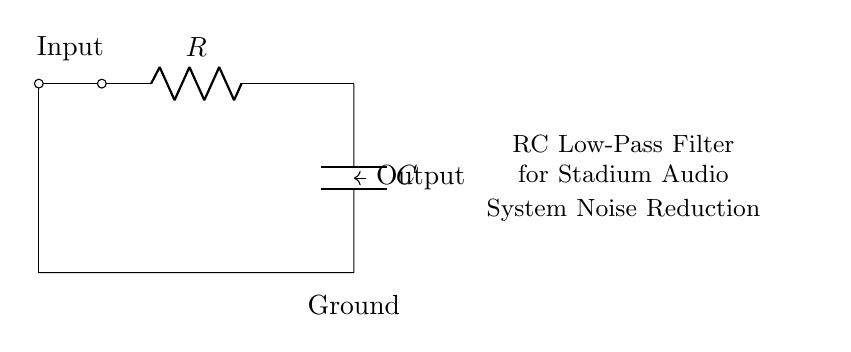What are the components in the circuit? The components visible in the circuit diagram are a resistor and a capacitor. These are essential to the functioning of the RC low-pass filter.
Answer: Resistor and capacitor What is the configuration of the circuit? The circuit is an RC low-pass filter where the resistor is connected in series with the capacitor, which is connected to ground. This arrangement allows low-frequency signals to pass while attenuating high-frequency noise.
Answer: Series configuration What does the input node do? The input node is where the audio signal enters the circuit, which will be filtered to reduce noise before reaching the output.
Answer: Filters audio signal What is the purpose of the capacitor? The capacitor stores electrical energy and interacts with the resistor to determine the cutoff frequency, allowing low frequencies to pass while blocking high frequencies.
Answer: Stores energy What is the function of the resistor in this circuit? The resistor limits the current flow and, along with the capacitor, sets the cutoff frequency for noise reduction. Its value directly influences the filter's behavior.
Answer: Limits current flow What is the output node connected to? The output node is connected to the filtered audio signal, which is taken from the junction between the resistor and the capacitor before going to further audio processing.
Answer: Filtered audio signal What does the term "cutoff frequency" imply in this context? The cutoff frequency is the frequency at which the output signal is reduced to 70.7% of the input signal, determined by the resistor and capacitor values. It marks the transition between pass and stop bands for the filter.
Answer: Transition frequency 